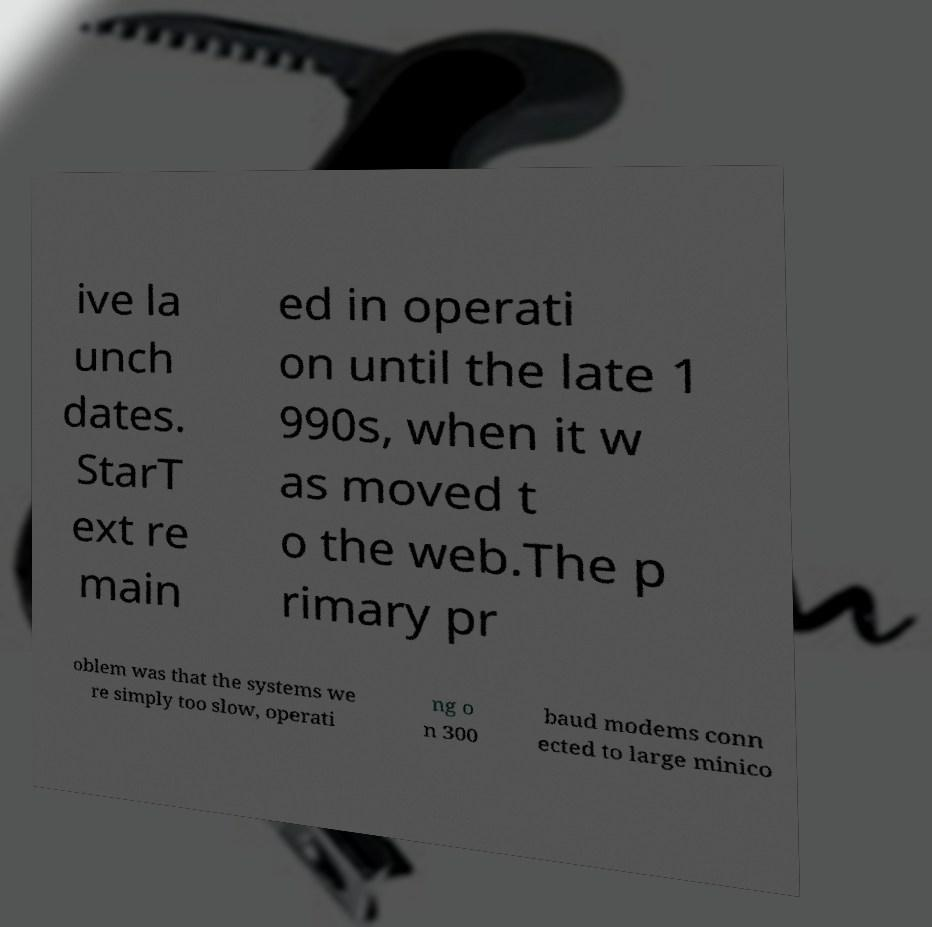What messages or text are displayed in this image? I need them in a readable, typed format. ive la unch dates. StarT ext re main ed in operati on until the late 1 990s, when it w as moved t o the web.The p rimary pr oblem was that the systems we re simply too slow, operati ng o n 300 baud modems conn ected to large minico 